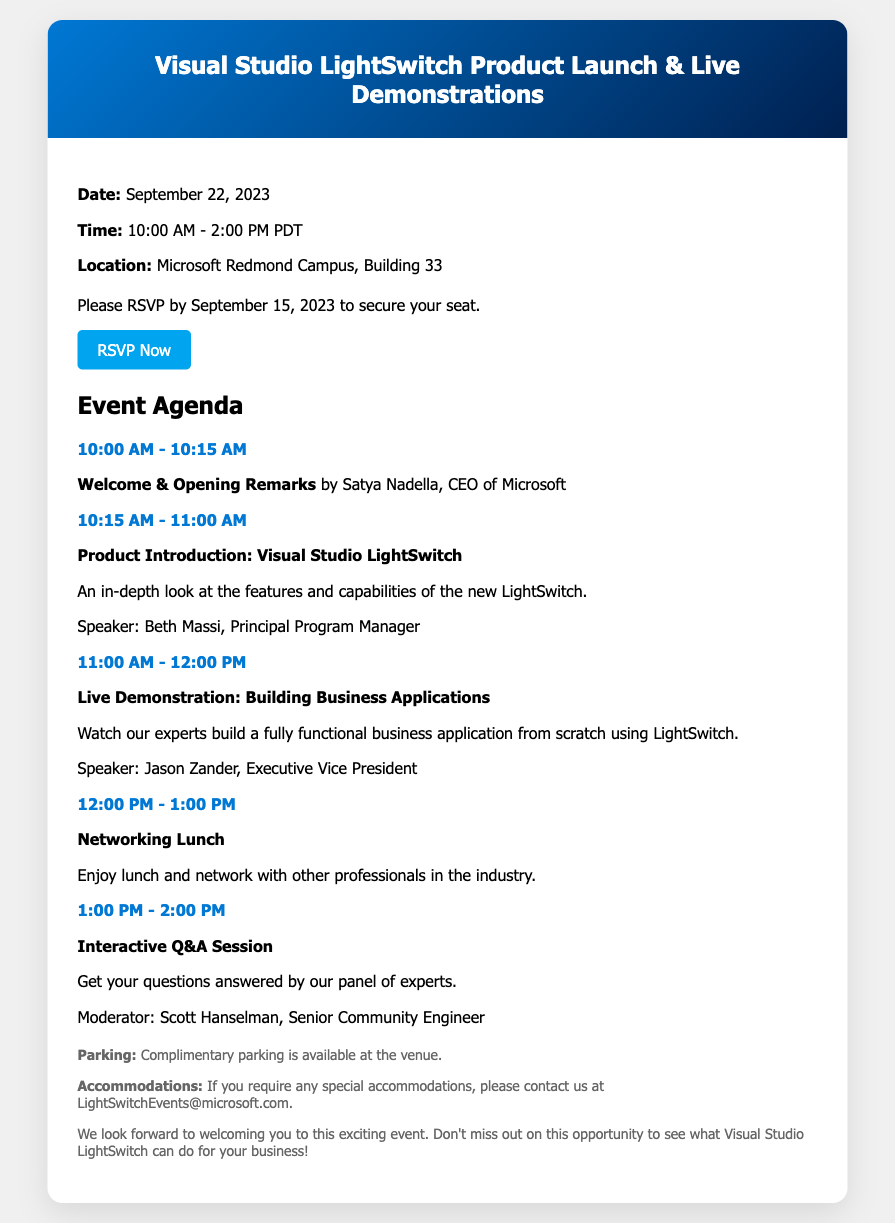what is the date of the event? The date of the event is explicitly stated in the document, which says "Date: September 22, 2023".
Answer: September 22, 2023 what time does the event start? The starting time of the event is mentioned as "10:00 AM - 2:00 PM PDT". The start time is 10:00 AM.
Answer: 10:00 AM who is giving the opening remarks? The document lists the opening remarks speaker as "Satya Nadella, CEO of Microsoft".
Answer: Satya Nadella what follows the live demonstration? The agenda indicates that after the live demonstration, there will be a "Networking Lunch".
Answer: Networking Lunch how should attendees RSVP? The RSVP instructions are provided in the document, with a link to RSVP stated as "RSVP Now".
Answer: RSVP Now what is the email for special accommodations? The document provides an email for contact regarding special accommodations as "LightSwitchEvents@microsoft.com".
Answer: LightSwitchEvents@microsoft.com how long is the live demonstration session? The duration of the live demonstration session is noted as "11:00 AM - 12:00 PM", which is one hour.
Answer: One hour what type of event is this? The event is specifically described in the heading and content, indicating it is a "Product Launch & Live Demonstrations".
Answer: Product Launch & Live Demonstrations 